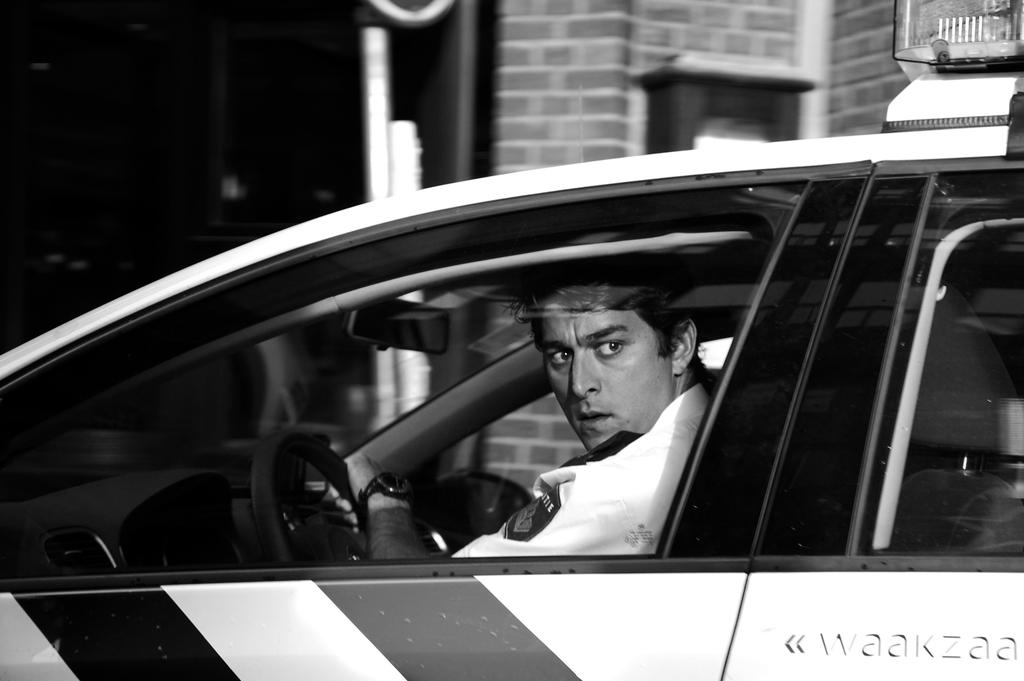What is the man in the image doing? The man is sitting in a car. What can be seen in the background of the image? There is a building and a pole in the background of the image. What type of milk is the man drinking in the image? There is no milk present in the image; the man is sitting in a car. Where is the man's desk located in the image? There is no desk present in the image; the man is sitting in a car. 